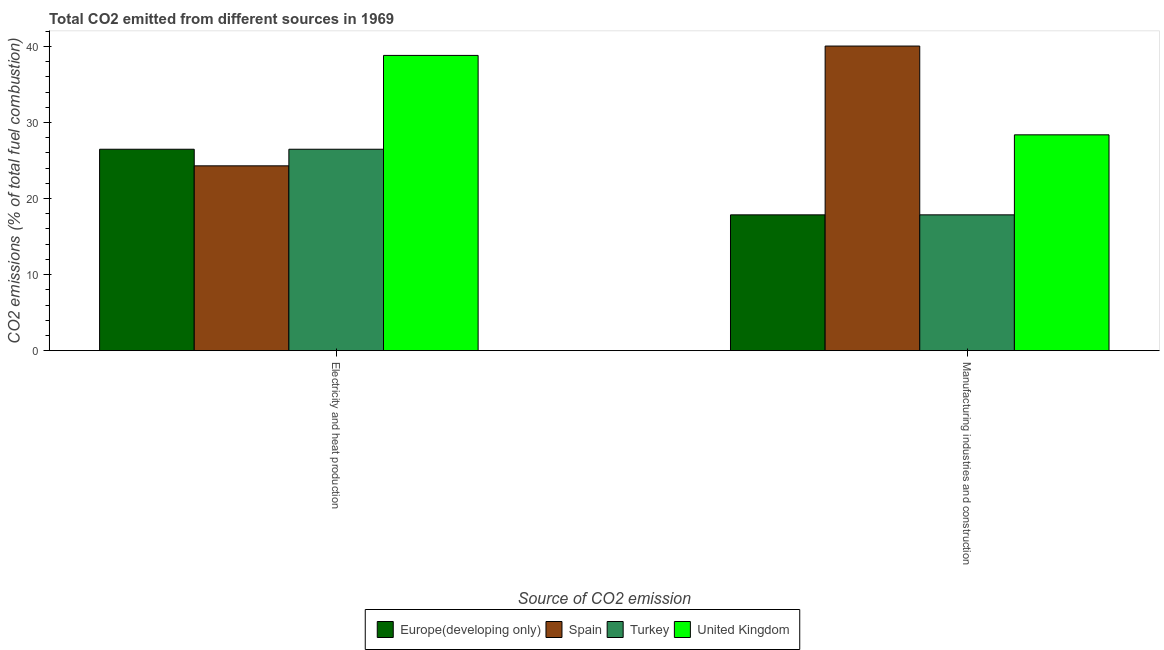How many different coloured bars are there?
Give a very brief answer. 4. Are the number of bars per tick equal to the number of legend labels?
Your answer should be compact. Yes. Are the number of bars on each tick of the X-axis equal?
Your response must be concise. Yes. How many bars are there on the 2nd tick from the right?
Provide a succinct answer. 4. What is the label of the 2nd group of bars from the left?
Give a very brief answer. Manufacturing industries and construction. What is the co2 emissions due to electricity and heat production in Spain?
Keep it short and to the point. 24.3. Across all countries, what is the maximum co2 emissions due to manufacturing industries?
Offer a terse response. 40.05. Across all countries, what is the minimum co2 emissions due to manufacturing industries?
Your response must be concise. 17.85. In which country was the co2 emissions due to manufacturing industries maximum?
Offer a very short reply. Spain. What is the total co2 emissions due to manufacturing industries in the graph?
Provide a short and direct response. 104.13. What is the difference between the co2 emissions due to manufacturing industries in United Kingdom and that in Europe(developing only)?
Keep it short and to the point. 10.52. What is the difference between the co2 emissions due to manufacturing industries in United Kingdom and the co2 emissions due to electricity and heat production in Spain?
Provide a short and direct response. 4.08. What is the average co2 emissions due to manufacturing industries per country?
Ensure brevity in your answer.  26.03. What is the difference between the co2 emissions due to electricity and heat production and co2 emissions due to manufacturing industries in Spain?
Keep it short and to the point. -15.75. What is the ratio of the co2 emissions due to manufacturing industries in United Kingdom to that in Spain?
Provide a succinct answer. 0.71. Is the co2 emissions due to manufacturing industries in Spain less than that in Turkey?
Your answer should be compact. No. What does the 1st bar from the left in Manufacturing industries and construction represents?
Give a very brief answer. Europe(developing only). What does the 4th bar from the right in Manufacturing industries and construction represents?
Your response must be concise. Europe(developing only). How many bars are there?
Keep it short and to the point. 8. How many countries are there in the graph?
Offer a very short reply. 4. Are the values on the major ticks of Y-axis written in scientific E-notation?
Provide a short and direct response. No. Does the graph contain grids?
Keep it short and to the point. No. What is the title of the graph?
Offer a terse response. Total CO2 emitted from different sources in 1969. Does "Fragile and conflict affected situations" appear as one of the legend labels in the graph?
Your answer should be very brief. No. What is the label or title of the X-axis?
Give a very brief answer. Source of CO2 emission. What is the label or title of the Y-axis?
Give a very brief answer. CO2 emissions (% of total fuel combustion). What is the CO2 emissions (% of total fuel combustion) in Europe(developing only) in Electricity and heat production?
Offer a very short reply. 26.48. What is the CO2 emissions (% of total fuel combustion) of Spain in Electricity and heat production?
Offer a terse response. 24.3. What is the CO2 emissions (% of total fuel combustion) of Turkey in Electricity and heat production?
Provide a succinct answer. 26.48. What is the CO2 emissions (% of total fuel combustion) in United Kingdom in Electricity and heat production?
Provide a short and direct response. 38.82. What is the CO2 emissions (% of total fuel combustion) of Europe(developing only) in Manufacturing industries and construction?
Your response must be concise. 17.85. What is the CO2 emissions (% of total fuel combustion) in Spain in Manufacturing industries and construction?
Provide a short and direct response. 40.05. What is the CO2 emissions (% of total fuel combustion) in Turkey in Manufacturing industries and construction?
Offer a very short reply. 17.85. What is the CO2 emissions (% of total fuel combustion) of United Kingdom in Manufacturing industries and construction?
Provide a short and direct response. 28.37. Across all Source of CO2 emission, what is the maximum CO2 emissions (% of total fuel combustion) in Europe(developing only)?
Give a very brief answer. 26.48. Across all Source of CO2 emission, what is the maximum CO2 emissions (% of total fuel combustion) in Spain?
Provide a short and direct response. 40.05. Across all Source of CO2 emission, what is the maximum CO2 emissions (% of total fuel combustion) of Turkey?
Give a very brief answer. 26.48. Across all Source of CO2 emission, what is the maximum CO2 emissions (% of total fuel combustion) of United Kingdom?
Keep it short and to the point. 38.82. Across all Source of CO2 emission, what is the minimum CO2 emissions (% of total fuel combustion) of Europe(developing only)?
Ensure brevity in your answer.  17.85. Across all Source of CO2 emission, what is the minimum CO2 emissions (% of total fuel combustion) in Spain?
Provide a short and direct response. 24.3. Across all Source of CO2 emission, what is the minimum CO2 emissions (% of total fuel combustion) of Turkey?
Your answer should be very brief. 17.85. Across all Source of CO2 emission, what is the minimum CO2 emissions (% of total fuel combustion) of United Kingdom?
Offer a very short reply. 28.37. What is the total CO2 emissions (% of total fuel combustion) of Europe(developing only) in the graph?
Ensure brevity in your answer.  44.33. What is the total CO2 emissions (% of total fuel combustion) in Spain in the graph?
Your response must be concise. 64.34. What is the total CO2 emissions (% of total fuel combustion) in Turkey in the graph?
Keep it short and to the point. 44.33. What is the total CO2 emissions (% of total fuel combustion) in United Kingdom in the graph?
Your answer should be compact. 67.19. What is the difference between the CO2 emissions (% of total fuel combustion) of Europe(developing only) in Electricity and heat production and that in Manufacturing industries and construction?
Offer a terse response. 8.62. What is the difference between the CO2 emissions (% of total fuel combustion) of Spain in Electricity and heat production and that in Manufacturing industries and construction?
Your answer should be very brief. -15.75. What is the difference between the CO2 emissions (% of total fuel combustion) of Turkey in Electricity and heat production and that in Manufacturing industries and construction?
Make the answer very short. 8.62. What is the difference between the CO2 emissions (% of total fuel combustion) in United Kingdom in Electricity and heat production and that in Manufacturing industries and construction?
Your answer should be compact. 10.44. What is the difference between the CO2 emissions (% of total fuel combustion) of Europe(developing only) in Electricity and heat production and the CO2 emissions (% of total fuel combustion) of Spain in Manufacturing industries and construction?
Offer a terse response. -13.57. What is the difference between the CO2 emissions (% of total fuel combustion) of Europe(developing only) in Electricity and heat production and the CO2 emissions (% of total fuel combustion) of Turkey in Manufacturing industries and construction?
Offer a very short reply. 8.62. What is the difference between the CO2 emissions (% of total fuel combustion) of Europe(developing only) in Electricity and heat production and the CO2 emissions (% of total fuel combustion) of United Kingdom in Manufacturing industries and construction?
Your answer should be compact. -1.89. What is the difference between the CO2 emissions (% of total fuel combustion) in Spain in Electricity and heat production and the CO2 emissions (% of total fuel combustion) in Turkey in Manufacturing industries and construction?
Provide a short and direct response. 6.44. What is the difference between the CO2 emissions (% of total fuel combustion) of Spain in Electricity and heat production and the CO2 emissions (% of total fuel combustion) of United Kingdom in Manufacturing industries and construction?
Make the answer very short. -4.08. What is the difference between the CO2 emissions (% of total fuel combustion) in Turkey in Electricity and heat production and the CO2 emissions (% of total fuel combustion) in United Kingdom in Manufacturing industries and construction?
Make the answer very short. -1.89. What is the average CO2 emissions (% of total fuel combustion) of Europe(developing only) per Source of CO2 emission?
Offer a very short reply. 22.17. What is the average CO2 emissions (% of total fuel combustion) in Spain per Source of CO2 emission?
Provide a succinct answer. 32.17. What is the average CO2 emissions (% of total fuel combustion) in Turkey per Source of CO2 emission?
Make the answer very short. 22.17. What is the average CO2 emissions (% of total fuel combustion) of United Kingdom per Source of CO2 emission?
Make the answer very short. 33.59. What is the difference between the CO2 emissions (% of total fuel combustion) in Europe(developing only) and CO2 emissions (% of total fuel combustion) in Spain in Electricity and heat production?
Make the answer very short. 2.18. What is the difference between the CO2 emissions (% of total fuel combustion) of Europe(developing only) and CO2 emissions (% of total fuel combustion) of Turkey in Electricity and heat production?
Ensure brevity in your answer.  0. What is the difference between the CO2 emissions (% of total fuel combustion) of Europe(developing only) and CO2 emissions (% of total fuel combustion) of United Kingdom in Electricity and heat production?
Provide a succinct answer. -12.34. What is the difference between the CO2 emissions (% of total fuel combustion) of Spain and CO2 emissions (% of total fuel combustion) of Turkey in Electricity and heat production?
Offer a very short reply. -2.18. What is the difference between the CO2 emissions (% of total fuel combustion) in Spain and CO2 emissions (% of total fuel combustion) in United Kingdom in Electricity and heat production?
Offer a very short reply. -14.52. What is the difference between the CO2 emissions (% of total fuel combustion) of Turkey and CO2 emissions (% of total fuel combustion) of United Kingdom in Electricity and heat production?
Provide a short and direct response. -12.34. What is the difference between the CO2 emissions (% of total fuel combustion) in Europe(developing only) and CO2 emissions (% of total fuel combustion) in Spain in Manufacturing industries and construction?
Provide a short and direct response. -22.19. What is the difference between the CO2 emissions (% of total fuel combustion) in Europe(developing only) and CO2 emissions (% of total fuel combustion) in Turkey in Manufacturing industries and construction?
Offer a terse response. 0. What is the difference between the CO2 emissions (% of total fuel combustion) of Europe(developing only) and CO2 emissions (% of total fuel combustion) of United Kingdom in Manufacturing industries and construction?
Give a very brief answer. -10.52. What is the difference between the CO2 emissions (% of total fuel combustion) of Spain and CO2 emissions (% of total fuel combustion) of Turkey in Manufacturing industries and construction?
Give a very brief answer. 22.19. What is the difference between the CO2 emissions (% of total fuel combustion) of Spain and CO2 emissions (% of total fuel combustion) of United Kingdom in Manufacturing industries and construction?
Your response must be concise. 11.67. What is the difference between the CO2 emissions (% of total fuel combustion) of Turkey and CO2 emissions (% of total fuel combustion) of United Kingdom in Manufacturing industries and construction?
Ensure brevity in your answer.  -10.52. What is the ratio of the CO2 emissions (% of total fuel combustion) in Europe(developing only) in Electricity and heat production to that in Manufacturing industries and construction?
Make the answer very short. 1.48. What is the ratio of the CO2 emissions (% of total fuel combustion) of Spain in Electricity and heat production to that in Manufacturing industries and construction?
Keep it short and to the point. 0.61. What is the ratio of the CO2 emissions (% of total fuel combustion) in Turkey in Electricity and heat production to that in Manufacturing industries and construction?
Provide a succinct answer. 1.48. What is the ratio of the CO2 emissions (% of total fuel combustion) of United Kingdom in Electricity and heat production to that in Manufacturing industries and construction?
Make the answer very short. 1.37. What is the difference between the highest and the second highest CO2 emissions (% of total fuel combustion) of Europe(developing only)?
Provide a short and direct response. 8.62. What is the difference between the highest and the second highest CO2 emissions (% of total fuel combustion) in Spain?
Your response must be concise. 15.75. What is the difference between the highest and the second highest CO2 emissions (% of total fuel combustion) in Turkey?
Make the answer very short. 8.62. What is the difference between the highest and the second highest CO2 emissions (% of total fuel combustion) of United Kingdom?
Your answer should be compact. 10.44. What is the difference between the highest and the lowest CO2 emissions (% of total fuel combustion) in Europe(developing only)?
Provide a succinct answer. 8.62. What is the difference between the highest and the lowest CO2 emissions (% of total fuel combustion) of Spain?
Your response must be concise. 15.75. What is the difference between the highest and the lowest CO2 emissions (% of total fuel combustion) in Turkey?
Give a very brief answer. 8.62. What is the difference between the highest and the lowest CO2 emissions (% of total fuel combustion) in United Kingdom?
Offer a very short reply. 10.44. 